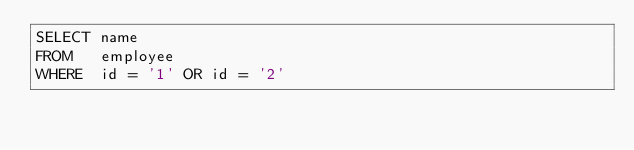Convert code to text. <code><loc_0><loc_0><loc_500><loc_500><_SQL_>SELECT name
FROM   employee
WHERE  id = '1' OR id = '2'
</code> 